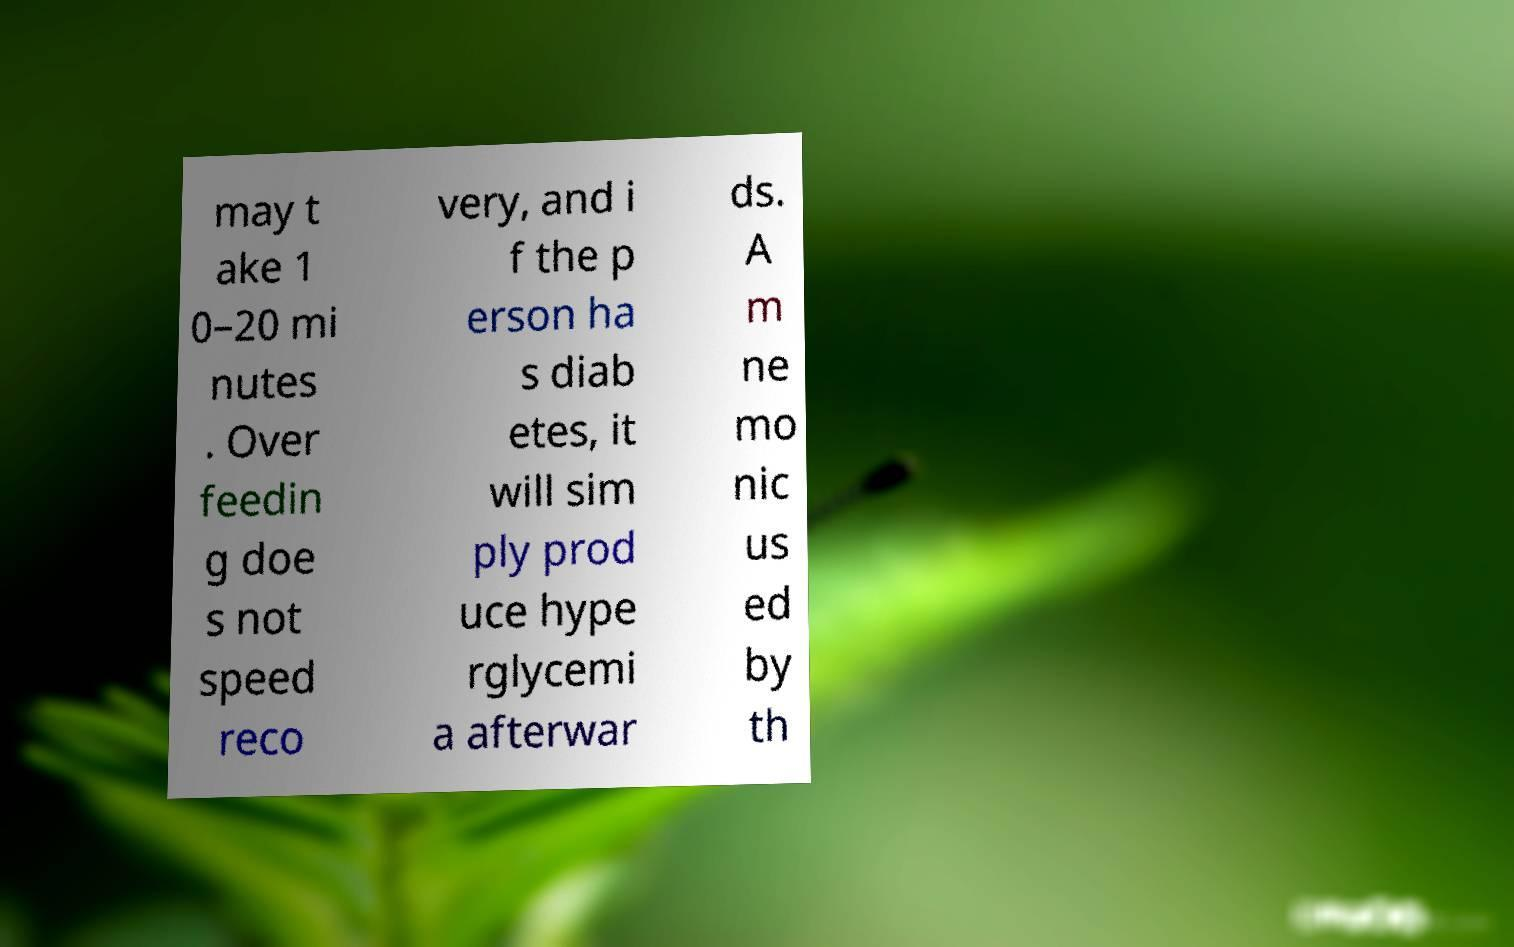Please identify and transcribe the text found in this image. may t ake 1 0–20 mi nutes . Over feedin g doe s not speed reco very, and i f the p erson ha s diab etes, it will sim ply prod uce hype rglycemi a afterwar ds. A m ne mo nic us ed by th 